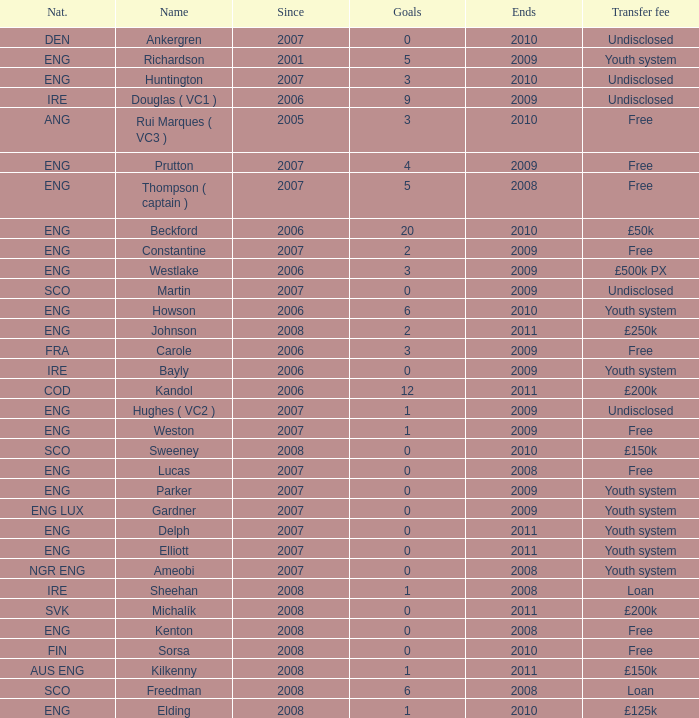Specify the typical extremities for weston. 2009.0. 